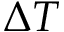Convert formula to latex. <formula><loc_0><loc_0><loc_500><loc_500>\Delta T</formula> 